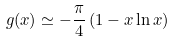Convert formula to latex. <formula><loc_0><loc_0><loc_500><loc_500>g ( x ) \simeq - \frac { \pi } { 4 } \left ( 1 - x \ln x \right )</formula> 